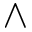Convert formula to latex. <formula><loc_0><loc_0><loc_500><loc_500>\wedge</formula> 